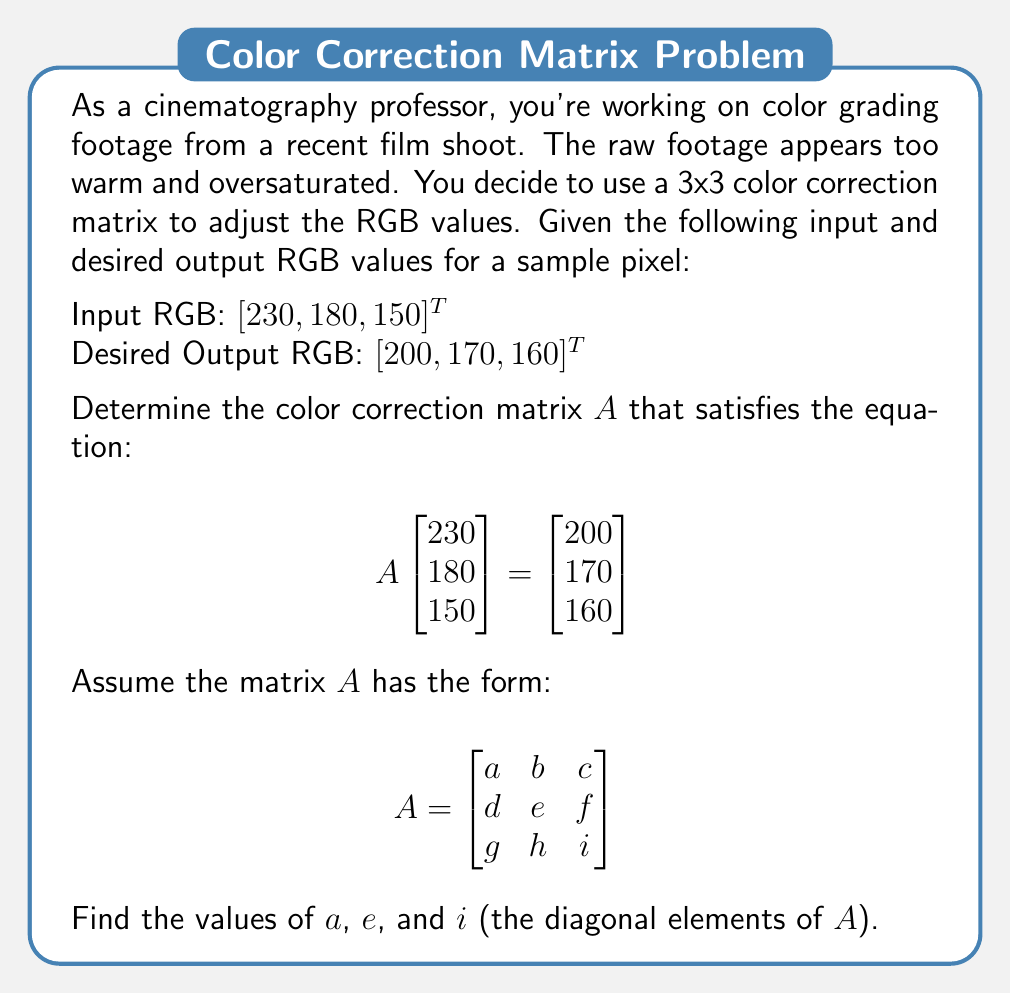Give your solution to this math problem. Let's approach this step-by-step:

1) The equation we need to solve is:

   $$\begin{bmatrix} a & b & c \\ d & e & f \\ g & h & i \end{bmatrix} \begin{bmatrix} 230 \\ 180 \\ 150 \end{bmatrix} = \begin{bmatrix} 200 \\ 170 \\ 160 \end{bmatrix}$$

2) This expands to three equations:

   $$230a + 180b + 150c = 200$$
   $$230d + 180e + 150f = 170$$
   $$230g + 180h + 150i = 160$$

3) We're only asked to find $a$, $e$, and $i$. These are the coefficients of the red, green, and blue channels respectively in their own output equations.

4) To simplify, let's assume that each output color is only affected by its corresponding input color. This means $b=c=d=f=g=h=0$.

5) Our equations now simplify to:

   $$230a = 200$$
   $$180e = 170$$
   $$150i = 160$$

6) Solving these:

   $$a = 200/230 \approx 0.8696$$
   $$e = 170/180 \approx 0.9444$$
   $$i = 160/150 \approx 1.0667$$

These values make sense in the context of color correction:
- $a < 1$ reduces the red channel (cooling the image)
- $e < 1$ slightly reduces the green channel
- $i > 1$ increases the blue channel (further cooling the image)
Answer: $a \approx 0.8696$, $e \approx 0.9444$, $i \approx 1.0667$ 